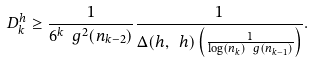<formula> <loc_0><loc_0><loc_500><loc_500>D ^ { h } _ { k } \geq \frac { 1 } { 6 ^ { k } \ g ^ { 2 } ( n _ { k - 2 } ) } \frac { 1 } { \Delta ( h , \ h ) \left ( \frac { 1 } { \log ( n _ { k } ) \ g ( n _ { k - 1 } ) } \right ) } .</formula> 